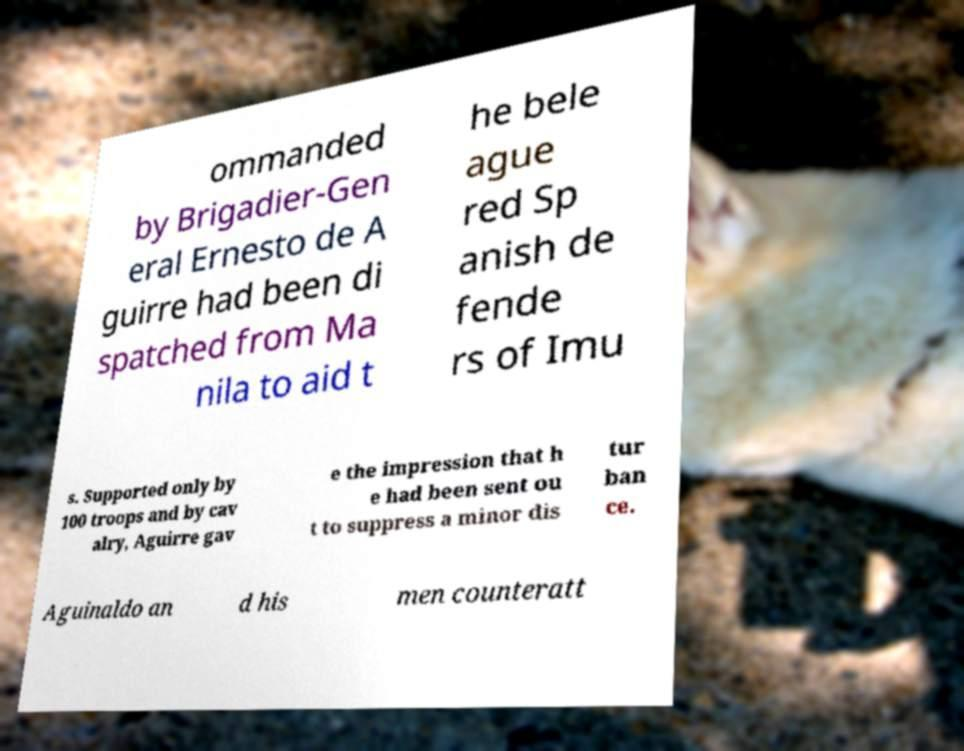Please identify and transcribe the text found in this image. ommanded by Brigadier-Gen eral Ernesto de A guirre had been di spatched from Ma nila to aid t he bele ague red Sp anish de fende rs of Imu s. Supported only by 100 troops and by cav alry, Aguirre gav e the impression that h e had been sent ou t to suppress a minor dis tur ban ce. Aguinaldo an d his men counteratt 